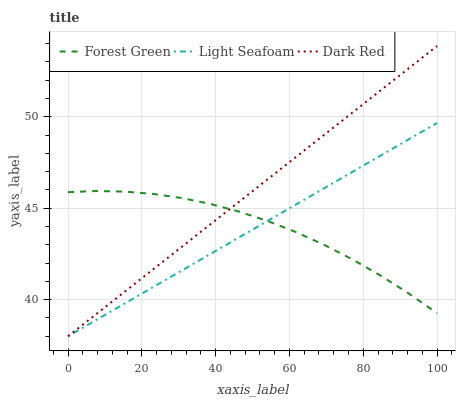Does Light Seafoam have the minimum area under the curve?
Answer yes or no. Yes. Does Dark Red have the maximum area under the curve?
Answer yes or no. Yes. Does Forest Green have the minimum area under the curve?
Answer yes or no. No. Does Forest Green have the maximum area under the curve?
Answer yes or no. No. Is Dark Red the smoothest?
Answer yes or no. Yes. Is Forest Green the roughest?
Answer yes or no. Yes. Is Light Seafoam the smoothest?
Answer yes or no. No. Is Light Seafoam the roughest?
Answer yes or no. No. Does Dark Red have the lowest value?
Answer yes or no. Yes. Does Forest Green have the lowest value?
Answer yes or no. No. Does Dark Red have the highest value?
Answer yes or no. Yes. Does Light Seafoam have the highest value?
Answer yes or no. No. Does Dark Red intersect Light Seafoam?
Answer yes or no. Yes. Is Dark Red less than Light Seafoam?
Answer yes or no. No. Is Dark Red greater than Light Seafoam?
Answer yes or no. No. 